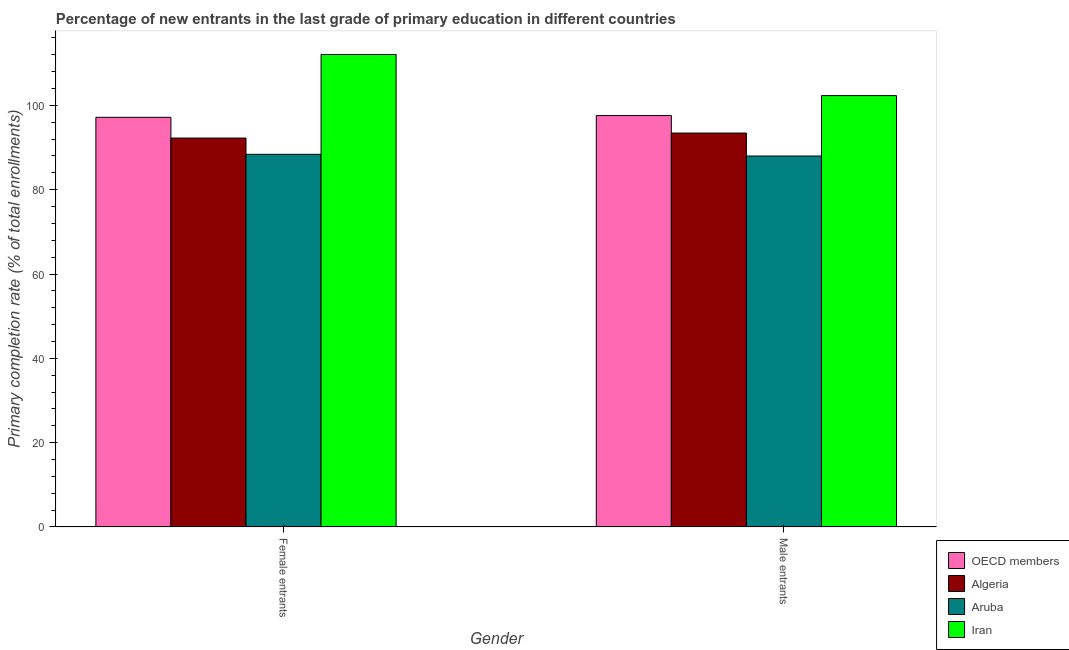How many different coloured bars are there?
Offer a very short reply. 4. How many groups of bars are there?
Keep it short and to the point. 2. How many bars are there on the 1st tick from the right?
Keep it short and to the point. 4. What is the label of the 2nd group of bars from the left?
Your answer should be very brief. Male entrants. What is the primary completion rate of female entrants in Aruba?
Ensure brevity in your answer.  88.4. Across all countries, what is the maximum primary completion rate of female entrants?
Give a very brief answer. 112.09. Across all countries, what is the minimum primary completion rate of male entrants?
Your answer should be very brief. 87.99. In which country was the primary completion rate of female entrants maximum?
Your answer should be compact. Iran. In which country was the primary completion rate of male entrants minimum?
Your answer should be compact. Aruba. What is the total primary completion rate of female entrants in the graph?
Your answer should be compact. 389.91. What is the difference between the primary completion rate of female entrants in Aruba and that in Iran?
Provide a short and direct response. -23.69. What is the difference between the primary completion rate of male entrants in OECD members and the primary completion rate of female entrants in Algeria?
Provide a short and direct response. 5.34. What is the average primary completion rate of male entrants per country?
Give a very brief answer. 95.34. What is the difference between the primary completion rate of male entrants and primary completion rate of female entrants in Iran?
Give a very brief answer. -9.77. What is the ratio of the primary completion rate of male entrants in Iran to that in Aruba?
Keep it short and to the point. 1.16. Is the primary completion rate of female entrants in Algeria less than that in Iran?
Offer a very short reply. Yes. In how many countries, is the primary completion rate of female entrants greater than the average primary completion rate of female entrants taken over all countries?
Your answer should be compact. 1. What does the 2nd bar from the left in Female entrants represents?
Offer a very short reply. Algeria. What does the 4th bar from the right in Male entrants represents?
Ensure brevity in your answer.  OECD members. Are all the bars in the graph horizontal?
Keep it short and to the point. No. How many countries are there in the graph?
Provide a succinct answer. 4. What is the difference between two consecutive major ticks on the Y-axis?
Make the answer very short. 20. Does the graph contain any zero values?
Offer a terse response. No. How many legend labels are there?
Make the answer very short. 4. How are the legend labels stacked?
Make the answer very short. Vertical. What is the title of the graph?
Keep it short and to the point. Percentage of new entrants in the last grade of primary education in different countries. Does "Small states" appear as one of the legend labels in the graph?
Provide a short and direct response. No. What is the label or title of the X-axis?
Ensure brevity in your answer.  Gender. What is the label or title of the Y-axis?
Offer a very short reply. Primary completion rate (% of total enrollments). What is the Primary completion rate (% of total enrollments) of OECD members in Female entrants?
Give a very brief answer. 97.17. What is the Primary completion rate (% of total enrollments) of Algeria in Female entrants?
Offer a terse response. 92.25. What is the Primary completion rate (% of total enrollments) in Aruba in Female entrants?
Ensure brevity in your answer.  88.4. What is the Primary completion rate (% of total enrollments) in Iran in Female entrants?
Provide a short and direct response. 112.09. What is the Primary completion rate (% of total enrollments) in OECD members in Male entrants?
Your response must be concise. 97.59. What is the Primary completion rate (% of total enrollments) of Algeria in Male entrants?
Provide a succinct answer. 93.44. What is the Primary completion rate (% of total enrollments) in Aruba in Male entrants?
Give a very brief answer. 87.99. What is the Primary completion rate (% of total enrollments) of Iran in Male entrants?
Offer a terse response. 102.32. Across all Gender, what is the maximum Primary completion rate (% of total enrollments) in OECD members?
Your response must be concise. 97.59. Across all Gender, what is the maximum Primary completion rate (% of total enrollments) in Algeria?
Your answer should be compact. 93.44. Across all Gender, what is the maximum Primary completion rate (% of total enrollments) in Aruba?
Offer a terse response. 88.4. Across all Gender, what is the maximum Primary completion rate (% of total enrollments) in Iran?
Give a very brief answer. 112.09. Across all Gender, what is the minimum Primary completion rate (% of total enrollments) in OECD members?
Offer a terse response. 97.17. Across all Gender, what is the minimum Primary completion rate (% of total enrollments) of Algeria?
Keep it short and to the point. 92.25. Across all Gender, what is the minimum Primary completion rate (% of total enrollments) of Aruba?
Make the answer very short. 87.99. Across all Gender, what is the minimum Primary completion rate (% of total enrollments) in Iran?
Offer a terse response. 102.32. What is the total Primary completion rate (% of total enrollments) of OECD members in the graph?
Offer a very short reply. 194.76. What is the total Primary completion rate (% of total enrollments) in Algeria in the graph?
Provide a succinct answer. 185.69. What is the total Primary completion rate (% of total enrollments) of Aruba in the graph?
Ensure brevity in your answer.  176.39. What is the total Primary completion rate (% of total enrollments) of Iran in the graph?
Keep it short and to the point. 214.41. What is the difference between the Primary completion rate (% of total enrollments) of OECD members in Female entrants and that in Male entrants?
Your response must be concise. -0.42. What is the difference between the Primary completion rate (% of total enrollments) in Algeria in Female entrants and that in Male entrants?
Your answer should be very brief. -1.19. What is the difference between the Primary completion rate (% of total enrollments) of Aruba in Female entrants and that in Male entrants?
Your answer should be very brief. 0.4. What is the difference between the Primary completion rate (% of total enrollments) of Iran in Female entrants and that in Male entrants?
Ensure brevity in your answer.  9.77. What is the difference between the Primary completion rate (% of total enrollments) of OECD members in Female entrants and the Primary completion rate (% of total enrollments) of Algeria in Male entrants?
Keep it short and to the point. 3.73. What is the difference between the Primary completion rate (% of total enrollments) of OECD members in Female entrants and the Primary completion rate (% of total enrollments) of Aruba in Male entrants?
Your answer should be very brief. 9.18. What is the difference between the Primary completion rate (% of total enrollments) in OECD members in Female entrants and the Primary completion rate (% of total enrollments) in Iran in Male entrants?
Provide a short and direct response. -5.15. What is the difference between the Primary completion rate (% of total enrollments) in Algeria in Female entrants and the Primary completion rate (% of total enrollments) in Aruba in Male entrants?
Your answer should be very brief. 4.26. What is the difference between the Primary completion rate (% of total enrollments) of Algeria in Female entrants and the Primary completion rate (% of total enrollments) of Iran in Male entrants?
Provide a succinct answer. -10.07. What is the difference between the Primary completion rate (% of total enrollments) in Aruba in Female entrants and the Primary completion rate (% of total enrollments) in Iran in Male entrants?
Offer a terse response. -13.92. What is the average Primary completion rate (% of total enrollments) in OECD members per Gender?
Offer a terse response. 97.38. What is the average Primary completion rate (% of total enrollments) of Algeria per Gender?
Your response must be concise. 92.85. What is the average Primary completion rate (% of total enrollments) in Aruba per Gender?
Keep it short and to the point. 88.2. What is the average Primary completion rate (% of total enrollments) in Iran per Gender?
Provide a succinct answer. 107.2. What is the difference between the Primary completion rate (% of total enrollments) of OECD members and Primary completion rate (% of total enrollments) of Algeria in Female entrants?
Give a very brief answer. 4.92. What is the difference between the Primary completion rate (% of total enrollments) of OECD members and Primary completion rate (% of total enrollments) of Aruba in Female entrants?
Your answer should be very brief. 8.77. What is the difference between the Primary completion rate (% of total enrollments) of OECD members and Primary completion rate (% of total enrollments) of Iran in Female entrants?
Provide a succinct answer. -14.91. What is the difference between the Primary completion rate (% of total enrollments) of Algeria and Primary completion rate (% of total enrollments) of Aruba in Female entrants?
Your answer should be compact. 3.85. What is the difference between the Primary completion rate (% of total enrollments) of Algeria and Primary completion rate (% of total enrollments) of Iran in Female entrants?
Provide a short and direct response. -19.83. What is the difference between the Primary completion rate (% of total enrollments) of Aruba and Primary completion rate (% of total enrollments) of Iran in Female entrants?
Provide a succinct answer. -23.69. What is the difference between the Primary completion rate (% of total enrollments) of OECD members and Primary completion rate (% of total enrollments) of Algeria in Male entrants?
Offer a terse response. 4.15. What is the difference between the Primary completion rate (% of total enrollments) of OECD members and Primary completion rate (% of total enrollments) of Aruba in Male entrants?
Give a very brief answer. 9.6. What is the difference between the Primary completion rate (% of total enrollments) in OECD members and Primary completion rate (% of total enrollments) in Iran in Male entrants?
Provide a short and direct response. -4.73. What is the difference between the Primary completion rate (% of total enrollments) in Algeria and Primary completion rate (% of total enrollments) in Aruba in Male entrants?
Your response must be concise. 5.45. What is the difference between the Primary completion rate (% of total enrollments) of Algeria and Primary completion rate (% of total enrollments) of Iran in Male entrants?
Keep it short and to the point. -8.88. What is the difference between the Primary completion rate (% of total enrollments) of Aruba and Primary completion rate (% of total enrollments) of Iran in Male entrants?
Your response must be concise. -14.32. What is the ratio of the Primary completion rate (% of total enrollments) of OECD members in Female entrants to that in Male entrants?
Your answer should be compact. 1. What is the ratio of the Primary completion rate (% of total enrollments) in Algeria in Female entrants to that in Male entrants?
Your answer should be very brief. 0.99. What is the ratio of the Primary completion rate (% of total enrollments) in Aruba in Female entrants to that in Male entrants?
Keep it short and to the point. 1. What is the ratio of the Primary completion rate (% of total enrollments) in Iran in Female entrants to that in Male entrants?
Offer a very short reply. 1.1. What is the difference between the highest and the second highest Primary completion rate (% of total enrollments) in OECD members?
Make the answer very short. 0.42. What is the difference between the highest and the second highest Primary completion rate (% of total enrollments) in Algeria?
Keep it short and to the point. 1.19. What is the difference between the highest and the second highest Primary completion rate (% of total enrollments) of Aruba?
Your answer should be very brief. 0.4. What is the difference between the highest and the second highest Primary completion rate (% of total enrollments) of Iran?
Keep it short and to the point. 9.77. What is the difference between the highest and the lowest Primary completion rate (% of total enrollments) of OECD members?
Offer a very short reply. 0.42. What is the difference between the highest and the lowest Primary completion rate (% of total enrollments) of Algeria?
Provide a succinct answer. 1.19. What is the difference between the highest and the lowest Primary completion rate (% of total enrollments) of Aruba?
Offer a very short reply. 0.4. What is the difference between the highest and the lowest Primary completion rate (% of total enrollments) in Iran?
Keep it short and to the point. 9.77. 